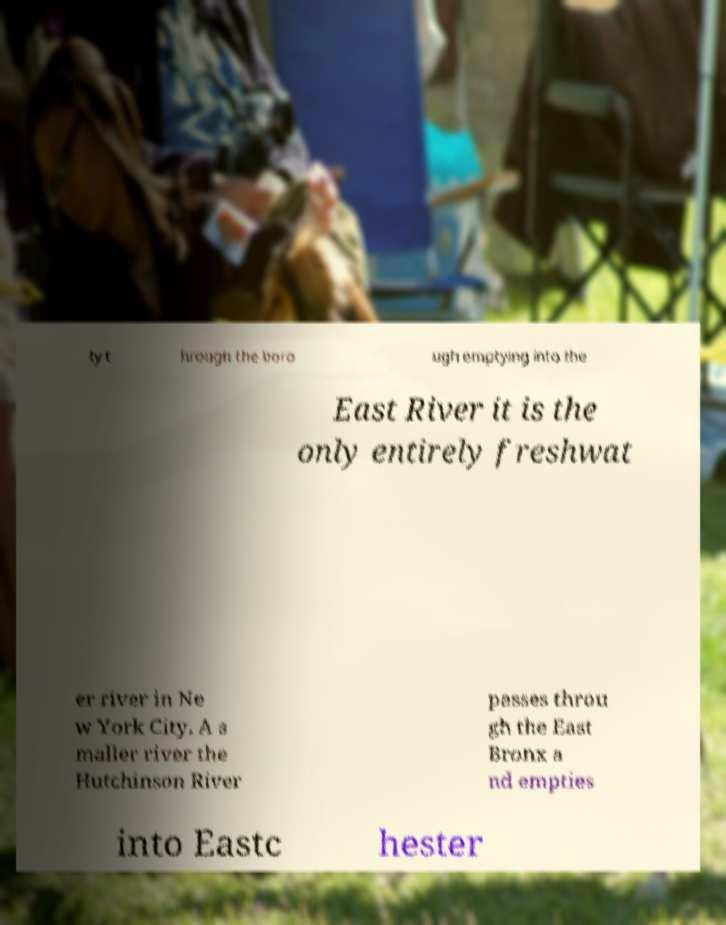I need the written content from this picture converted into text. Can you do that? ty t hrough the boro ugh emptying into the East River it is the only entirely freshwat er river in Ne w York City. A s maller river the Hutchinson River passes throu gh the East Bronx a nd empties into Eastc hester 